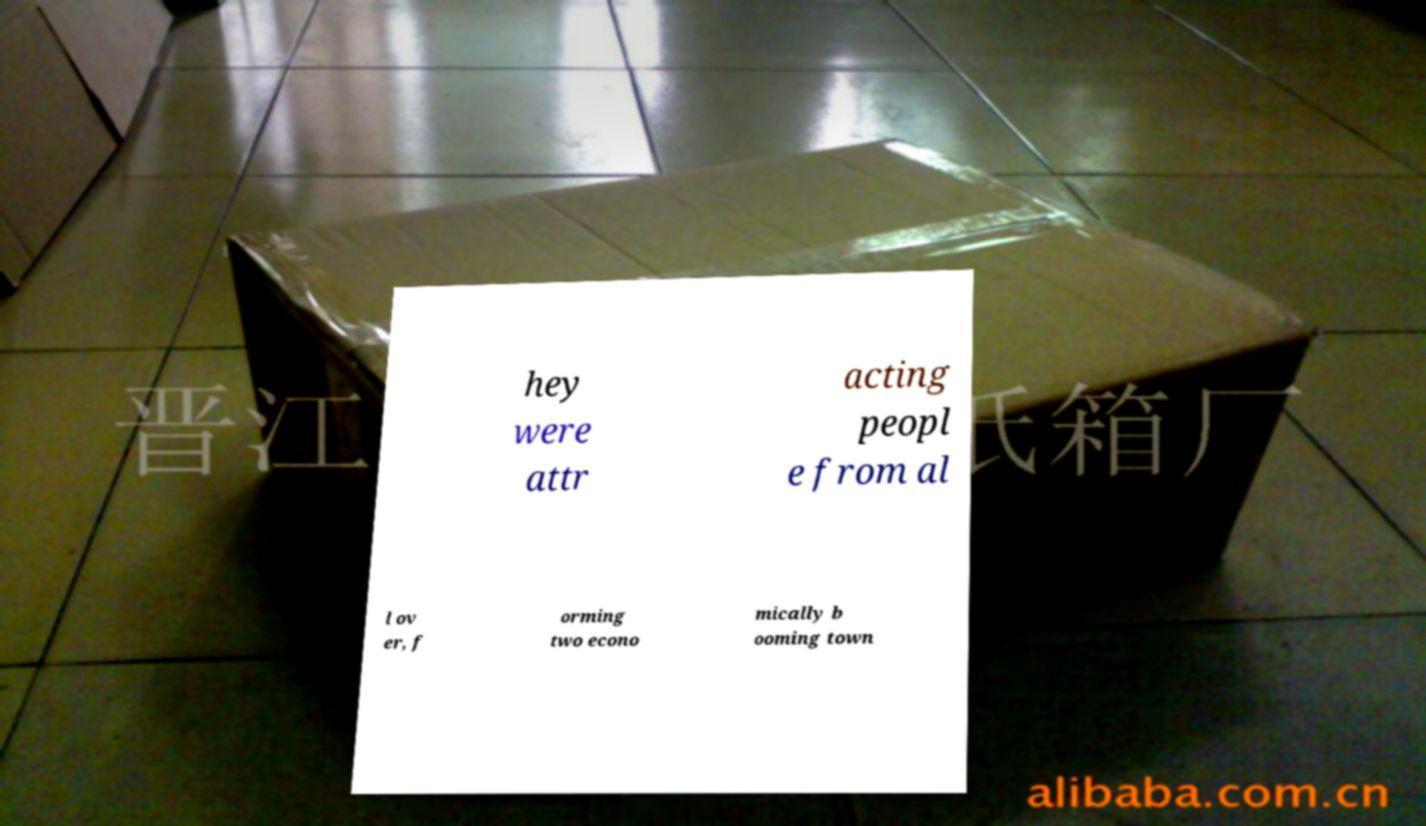Could you extract and type out the text from this image? hey were attr acting peopl e from al l ov er, f orming two econo mically b ooming town 